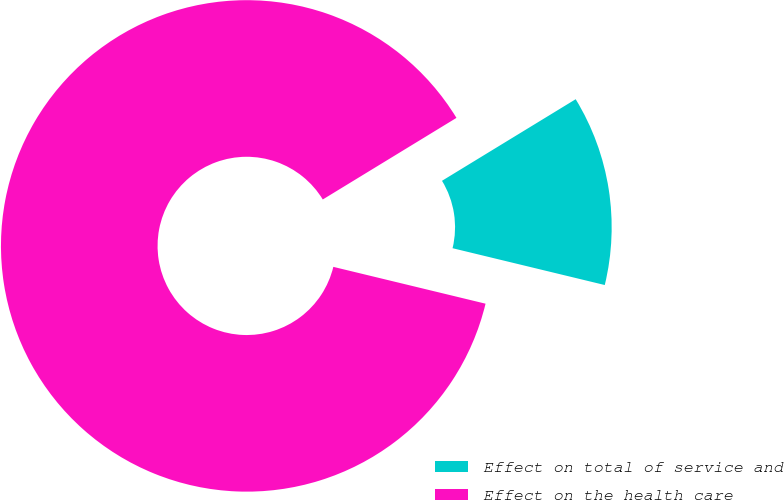Convert chart. <chart><loc_0><loc_0><loc_500><loc_500><pie_chart><fcel>Effect on total of service and<fcel>Effect on the health care<nl><fcel>12.5%<fcel>87.5%<nl></chart> 